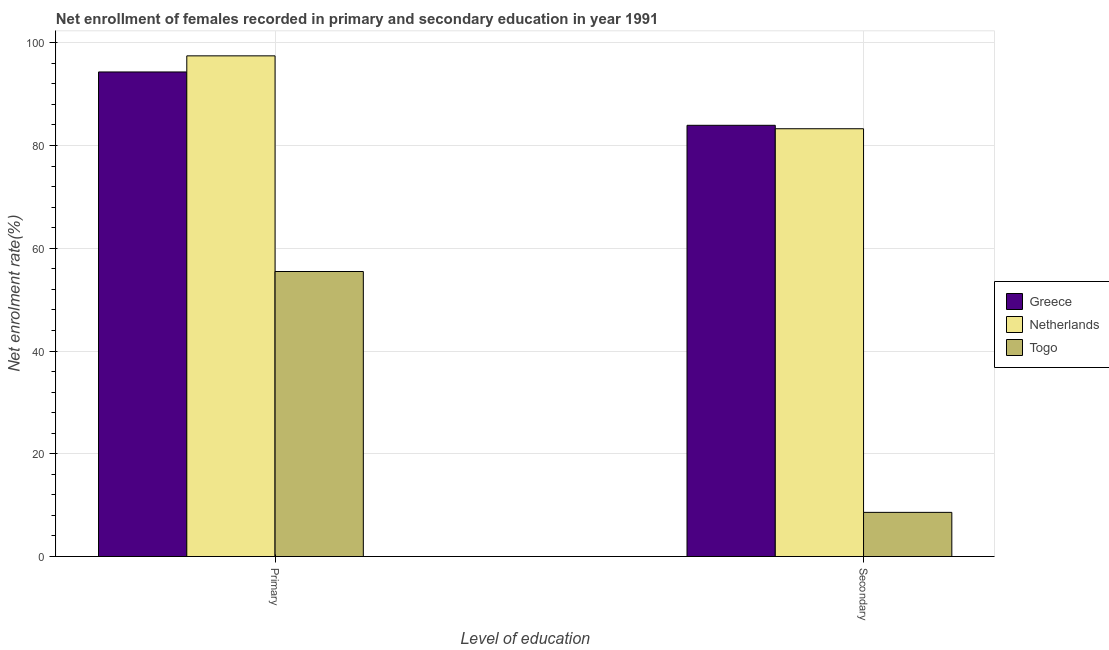Are the number of bars per tick equal to the number of legend labels?
Give a very brief answer. Yes. How many bars are there on the 2nd tick from the right?
Keep it short and to the point. 3. What is the label of the 1st group of bars from the left?
Your answer should be very brief. Primary. What is the enrollment rate in secondary education in Togo?
Give a very brief answer. 8.59. Across all countries, what is the maximum enrollment rate in secondary education?
Your answer should be very brief. 83.93. Across all countries, what is the minimum enrollment rate in secondary education?
Ensure brevity in your answer.  8.59. In which country was the enrollment rate in primary education minimum?
Ensure brevity in your answer.  Togo. What is the total enrollment rate in secondary education in the graph?
Ensure brevity in your answer.  175.79. What is the difference between the enrollment rate in secondary education in Togo and that in Greece?
Give a very brief answer. -75.34. What is the difference between the enrollment rate in primary education in Netherlands and the enrollment rate in secondary education in Greece?
Provide a succinct answer. 13.52. What is the average enrollment rate in primary education per country?
Provide a short and direct response. 82.41. What is the difference between the enrollment rate in primary education and enrollment rate in secondary education in Greece?
Your answer should be compact. 10.38. What is the ratio of the enrollment rate in secondary education in Togo to that in Netherlands?
Give a very brief answer. 0.1. In how many countries, is the enrollment rate in primary education greater than the average enrollment rate in primary education taken over all countries?
Offer a very short reply. 2. What does the 2nd bar from the left in Primary represents?
Offer a very short reply. Netherlands. What does the 3rd bar from the right in Primary represents?
Your response must be concise. Greece. Are all the bars in the graph horizontal?
Your response must be concise. No. Does the graph contain any zero values?
Offer a very short reply. No. Where does the legend appear in the graph?
Keep it short and to the point. Center right. How are the legend labels stacked?
Ensure brevity in your answer.  Vertical. What is the title of the graph?
Offer a very short reply. Net enrollment of females recorded in primary and secondary education in year 1991. What is the label or title of the X-axis?
Keep it short and to the point. Level of education. What is the label or title of the Y-axis?
Keep it short and to the point. Net enrolment rate(%). What is the Net enrolment rate(%) in Greece in Primary?
Provide a succinct answer. 94.32. What is the Net enrolment rate(%) in Netherlands in Primary?
Offer a very short reply. 97.45. What is the Net enrolment rate(%) in Togo in Primary?
Your answer should be very brief. 55.48. What is the Net enrolment rate(%) of Greece in Secondary?
Keep it short and to the point. 83.93. What is the Net enrolment rate(%) in Netherlands in Secondary?
Give a very brief answer. 83.26. What is the Net enrolment rate(%) in Togo in Secondary?
Provide a succinct answer. 8.59. Across all Level of education, what is the maximum Net enrolment rate(%) in Greece?
Offer a very short reply. 94.32. Across all Level of education, what is the maximum Net enrolment rate(%) in Netherlands?
Provide a short and direct response. 97.45. Across all Level of education, what is the maximum Net enrolment rate(%) of Togo?
Provide a succinct answer. 55.48. Across all Level of education, what is the minimum Net enrolment rate(%) in Greece?
Your answer should be very brief. 83.93. Across all Level of education, what is the minimum Net enrolment rate(%) of Netherlands?
Make the answer very short. 83.26. Across all Level of education, what is the minimum Net enrolment rate(%) of Togo?
Provide a succinct answer. 8.59. What is the total Net enrolment rate(%) of Greece in the graph?
Provide a short and direct response. 178.25. What is the total Net enrolment rate(%) of Netherlands in the graph?
Make the answer very short. 180.71. What is the total Net enrolment rate(%) in Togo in the graph?
Keep it short and to the point. 64.07. What is the difference between the Net enrolment rate(%) in Greece in Primary and that in Secondary?
Ensure brevity in your answer.  10.38. What is the difference between the Net enrolment rate(%) of Netherlands in Primary and that in Secondary?
Ensure brevity in your answer.  14.18. What is the difference between the Net enrolment rate(%) of Togo in Primary and that in Secondary?
Offer a very short reply. 46.88. What is the difference between the Net enrolment rate(%) of Greece in Primary and the Net enrolment rate(%) of Netherlands in Secondary?
Offer a terse response. 11.05. What is the difference between the Net enrolment rate(%) of Greece in Primary and the Net enrolment rate(%) of Togo in Secondary?
Give a very brief answer. 85.72. What is the difference between the Net enrolment rate(%) of Netherlands in Primary and the Net enrolment rate(%) of Togo in Secondary?
Keep it short and to the point. 88.86. What is the average Net enrolment rate(%) of Greece per Level of education?
Give a very brief answer. 89.12. What is the average Net enrolment rate(%) in Netherlands per Level of education?
Ensure brevity in your answer.  90.36. What is the average Net enrolment rate(%) in Togo per Level of education?
Ensure brevity in your answer.  32.03. What is the difference between the Net enrolment rate(%) in Greece and Net enrolment rate(%) in Netherlands in Primary?
Keep it short and to the point. -3.13. What is the difference between the Net enrolment rate(%) in Greece and Net enrolment rate(%) in Togo in Primary?
Make the answer very short. 38.84. What is the difference between the Net enrolment rate(%) in Netherlands and Net enrolment rate(%) in Togo in Primary?
Offer a very short reply. 41.97. What is the difference between the Net enrolment rate(%) in Greece and Net enrolment rate(%) in Netherlands in Secondary?
Give a very brief answer. 0.67. What is the difference between the Net enrolment rate(%) in Greece and Net enrolment rate(%) in Togo in Secondary?
Offer a very short reply. 75.34. What is the difference between the Net enrolment rate(%) of Netherlands and Net enrolment rate(%) of Togo in Secondary?
Provide a short and direct response. 74.67. What is the ratio of the Net enrolment rate(%) of Greece in Primary to that in Secondary?
Your response must be concise. 1.12. What is the ratio of the Net enrolment rate(%) of Netherlands in Primary to that in Secondary?
Give a very brief answer. 1.17. What is the ratio of the Net enrolment rate(%) of Togo in Primary to that in Secondary?
Your answer should be very brief. 6.46. What is the difference between the highest and the second highest Net enrolment rate(%) in Greece?
Give a very brief answer. 10.38. What is the difference between the highest and the second highest Net enrolment rate(%) in Netherlands?
Make the answer very short. 14.18. What is the difference between the highest and the second highest Net enrolment rate(%) in Togo?
Provide a succinct answer. 46.88. What is the difference between the highest and the lowest Net enrolment rate(%) of Greece?
Keep it short and to the point. 10.38. What is the difference between the highest and the lowest Net enrolment rate(%) of Netherlands?
Offer a very short reply. 14.18. What is the difference between the highest and the lowest Net enrolment rate(%) in Togo?
Your answer should be very brief. 46.88. 